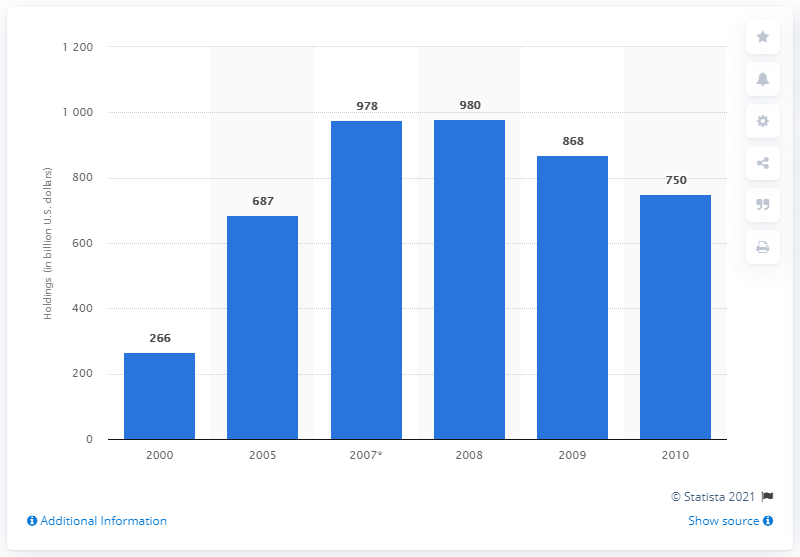Point out several critical features in this image. In 2008, the commercial banking sector held a significant amount of corporate and foreign bonds, estimated to be approximately 980. 